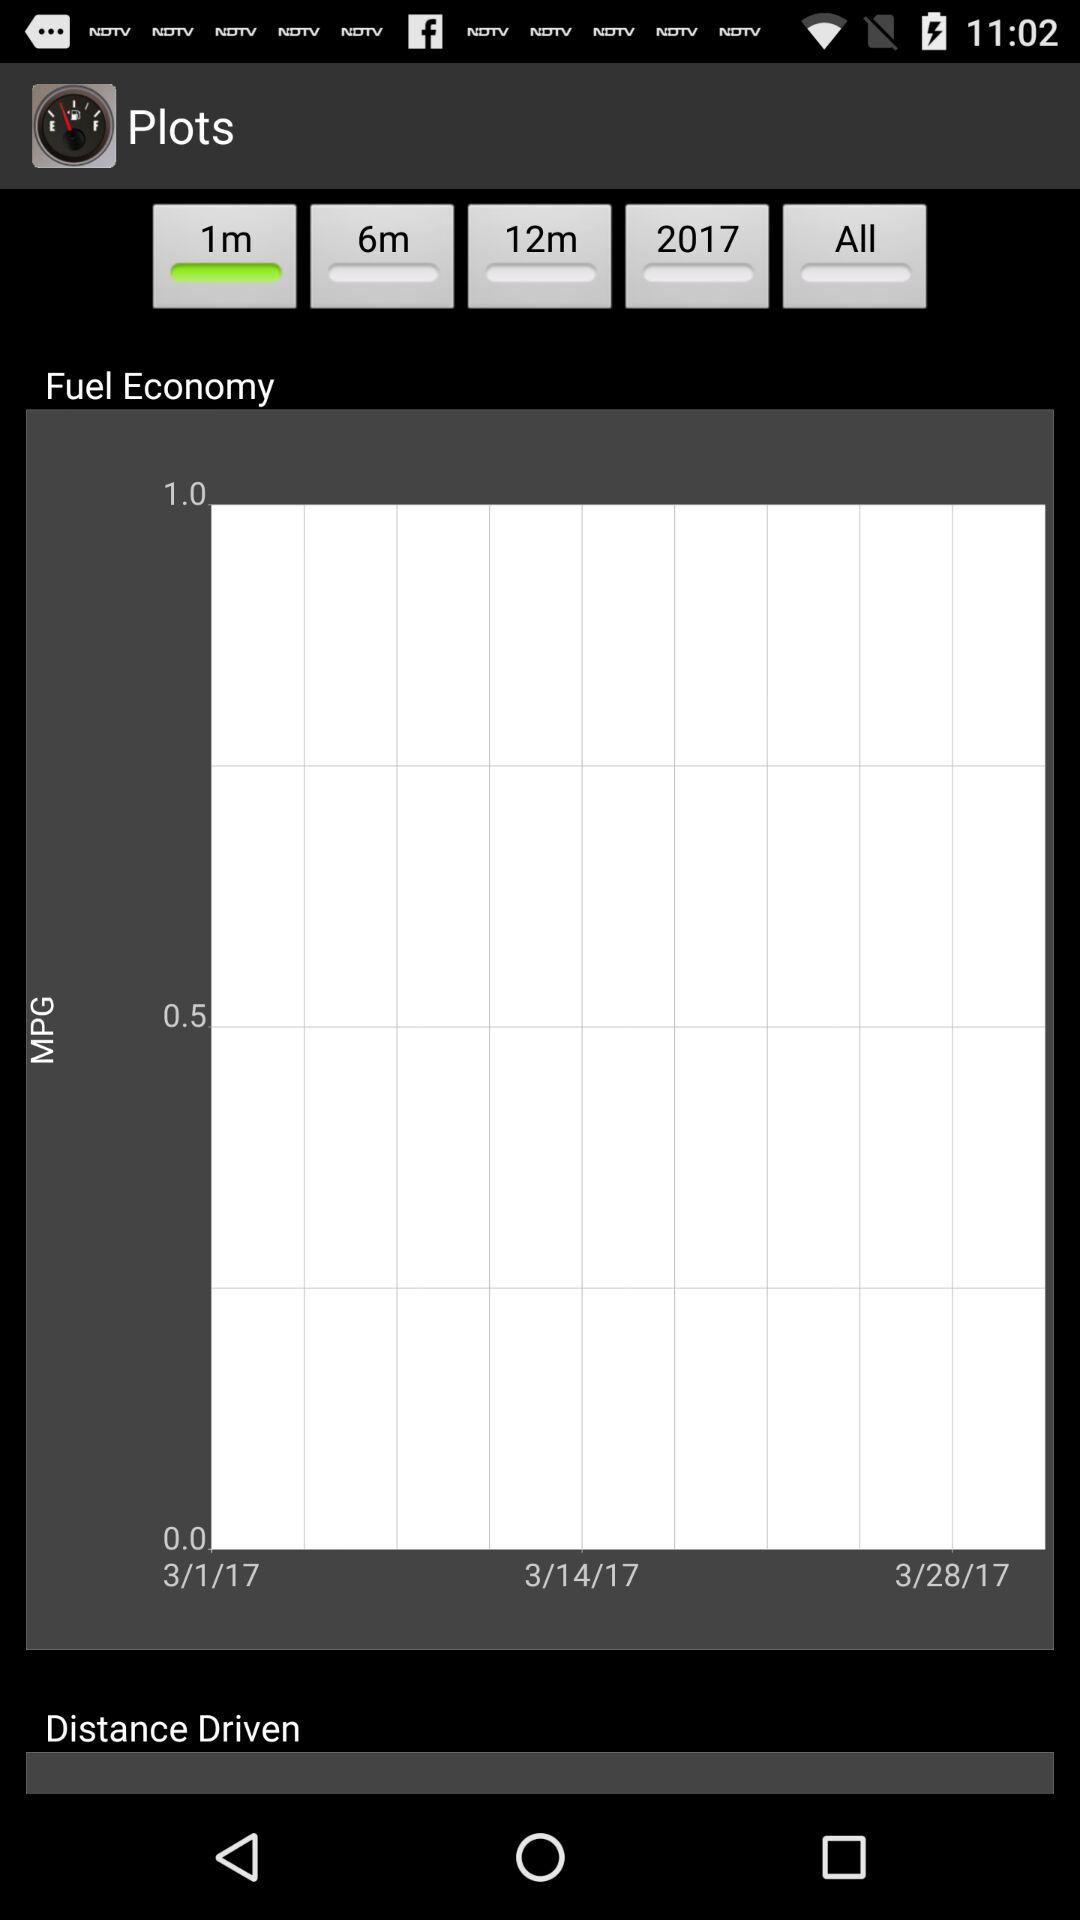How many days are represented in the data?
Answer the question using a single word or phrase. 3 